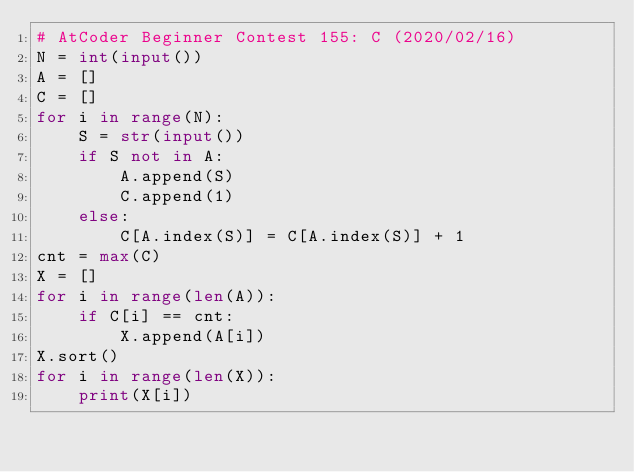<code> <loc_0><loc_0><loc_500><loc_500><_Python_># AtCoder Beginner Contest 155: C (2020/02/16)
N = int(input())
A = []
C = []
for i in range(N):
    S = str(input())
    if S not in A:
        A.append(S)
        C.append(1)
    else:
        C[A.index(S)] = C[A.index(S)] + 1
cnt = max(C)
X = []
for i in range(len(A)):
    if C[i] == cnt:
        X.append(A[i])
X.sort()
for i in range(len(X)):
    print(X[i])</code> 